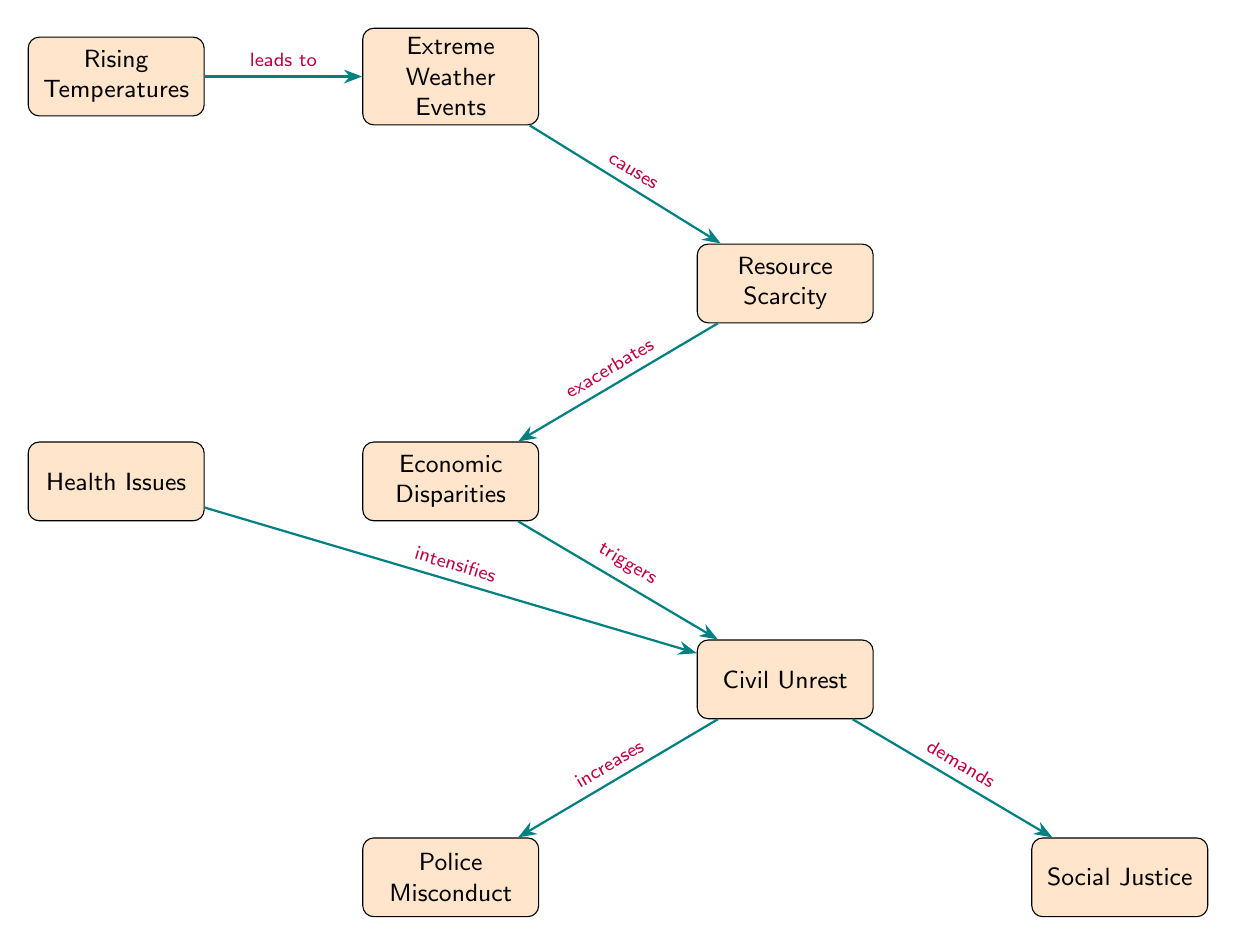What is the first node in the diagram? The first node in the diagram is "Rising Temperatures," which is positioned at the top and does not have any incoming arrows.
Answer: Rising Temperatures How many nodes are in the diagram? By counting the nodes represented in the diagram, we see a total of seven distinct nodes.
Answer: 7 What does "Rising Temperatures" lead to? The diagram indicates that "Rising Temperatures" directly leads to the "Extreme Weather Events" node, as indicated by the arrow.
Answer: Extreme Weather Events What does "Resource Scarcity" exacerbate? According to the diagram, "Resource Scarcity" exacerbates "Economic Disparities," as it is connected by the directed arrow from the former to the latter.
Answer: Economic Disparities How does "Civil Unrest" relate to "Police Misconduct"? The diagram shows that "Civil Unrest" increases "Police Misconduct," indicating a direct relationship between the two nodes.
Answer: Increases What is the relationship between "Health Issues" and "Civil Unrest"? The diagram shows that "Health Issues" intensifies "Civil Unrest," meaning that as health issues rise, civil unrest becomes worse.
Answer: Intensifies Which node demands "Social Justice"? The diagram clearly indicates that "Civil Unrest" demands "Social Justice," with a directed arrow pointing from one to the other.
Answer: Civil Unrest What causes "Resource Scarcity"? The diagram illustrates that "Extreme Weather Events" causes "Resource Scarcity," establishing a clear causal relationship.
Answer: Causes What is the final node in the flow of the diagram? The final node, where the flow ends and which accumulates effects from the previous nodes, is "Social Justice."
Answer: Social Justice 